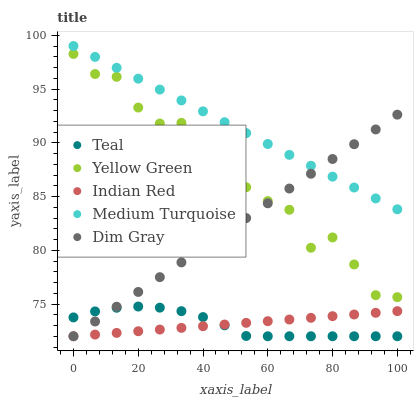Does Teal have the minimum area under the curve?
Answer yes or no. Yes. Does Medium Turquoise have the maximum area under the curve?
Answer yes or no. Yes. Does Dim Gray have the minimum area under the curve?
Answer yes or no. No. Does Dim Gray have the maximum area under the curve?
Answer yes or no. No. Is Dim Gray the smoothest?
Answer yes or no. Yes. Is Yellow Green the roughest?
Answer yes or no. Yes. Is Medium Turquoise the smoothest?
Answer yes or no. No. Is Medium Turquoise the roughest?
Answer yes or no. No. Does Indian Red have the lowest value?
Answer yes or no. Yes. Does Medium Turquoise have the lowest value?
Answer yes or no. No. Does Medium Turquoise have the highest value?
Answer yes or no. Yes. Does Dim Gray have the highest value?
Answer yes or no. No. Is Indian Red less than Medium Turquoise?
Answer yes or no. Yes. Is Medium Turquoise greater than Yellow Green?
Answer yes or no. Yes. Does Medium Turquoise intersect Dim Gray?
Answer yes or no. Yes. Is Medium Turquoise less than Dim Gray?
Answer yes or no. No. Is Medium Turquoise greater than Dim Gray?
Answer yes or no. No. Does Indian Red intersect Medium Turquoise?
Answer yes or no. No. 